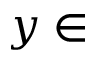Convert formula to latex. <formula><loc_0><loc_0><loc_500><loc_500>y \in</formula> 